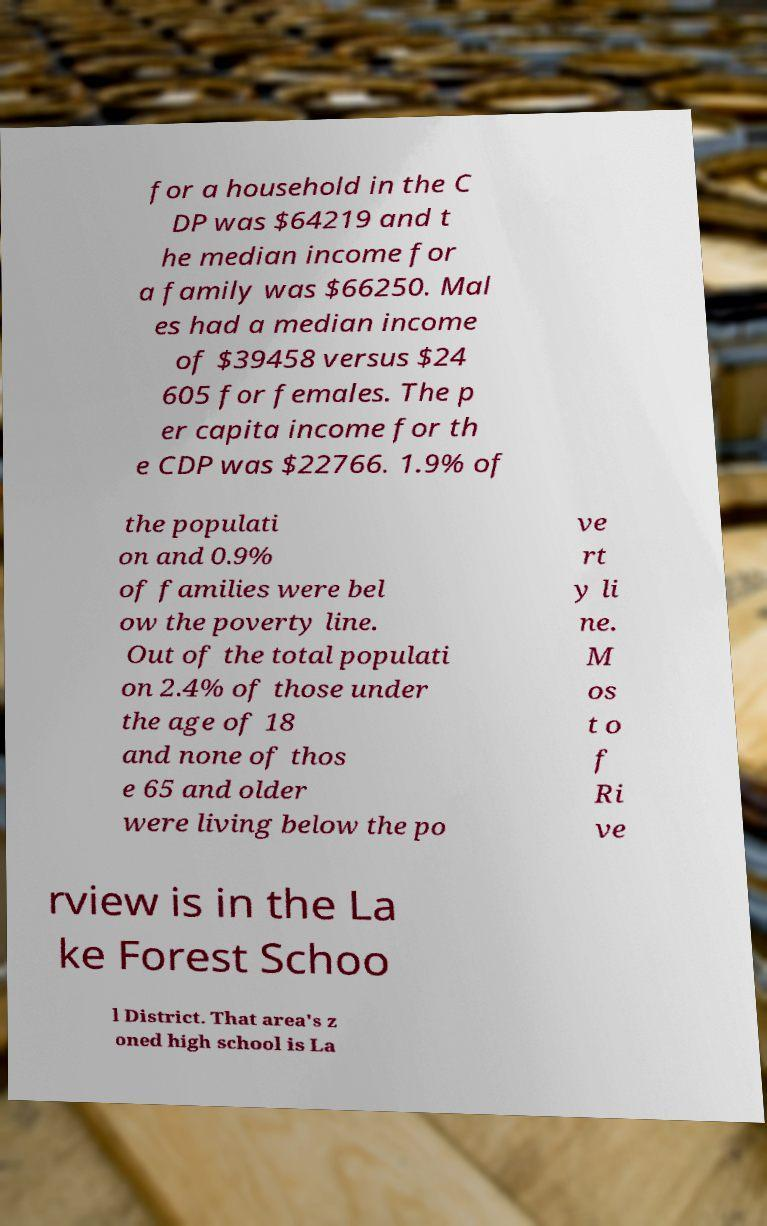Could you extract and type out the text from this image? for a household in the C DP was $64219 and t he median income for a family was $66250. Mal es had a median income of $39458 versus $24 605 for females. The p er capita income for th e CDP was $22766. 1.9% of the populati on and 0.9% of families were bel ow the poverty line. Out of the total populati on 2.4% of those under the age of 18 and none of thos e 65 and older were living below the po ve rt y li ne. M os t o f Ri ve rview is in the La ke Forest Schoo l District. That area's z oned high school is La 